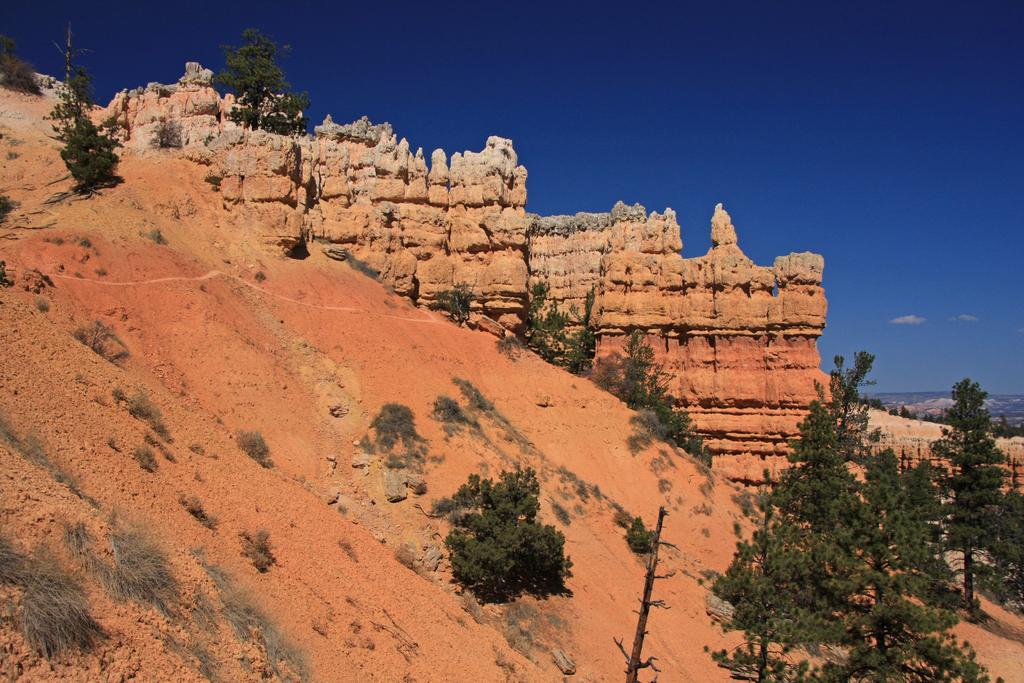What natural element can be seen in the image? The image contains the sky. What type of landform is visible in the image? There are hills in the image. What type of vegetation is present in the image? Trees are present in the image. What type of ground cover is visible in the image? Grass is visible in the image. What type of quicksand can be seen in the image? There is no quicksand present in the image. What type of society is depicted in the image? The image does not depict any society or social group. 